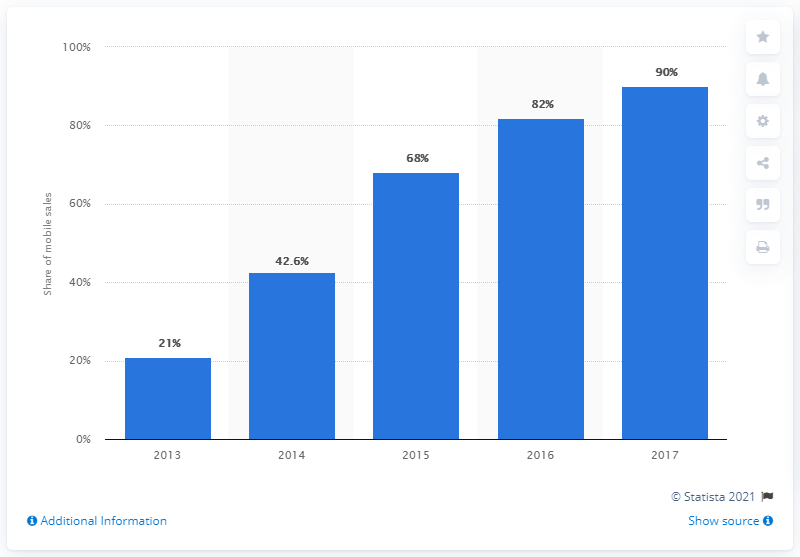Highlight a few significant elements in this photo. In 2017, mobile buyers accounted for approximately 90% of total GMV (Gross Merchandise Volume) on the ecommerce platform. 